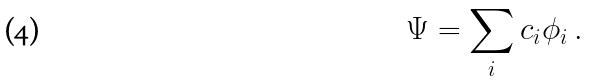Convert formula to latex. <formula><loc_0><loc_0><loc_500><loc_500>\Psi = \sum _ { i } c _ { i } \phi _ { i } \ .</formula> 